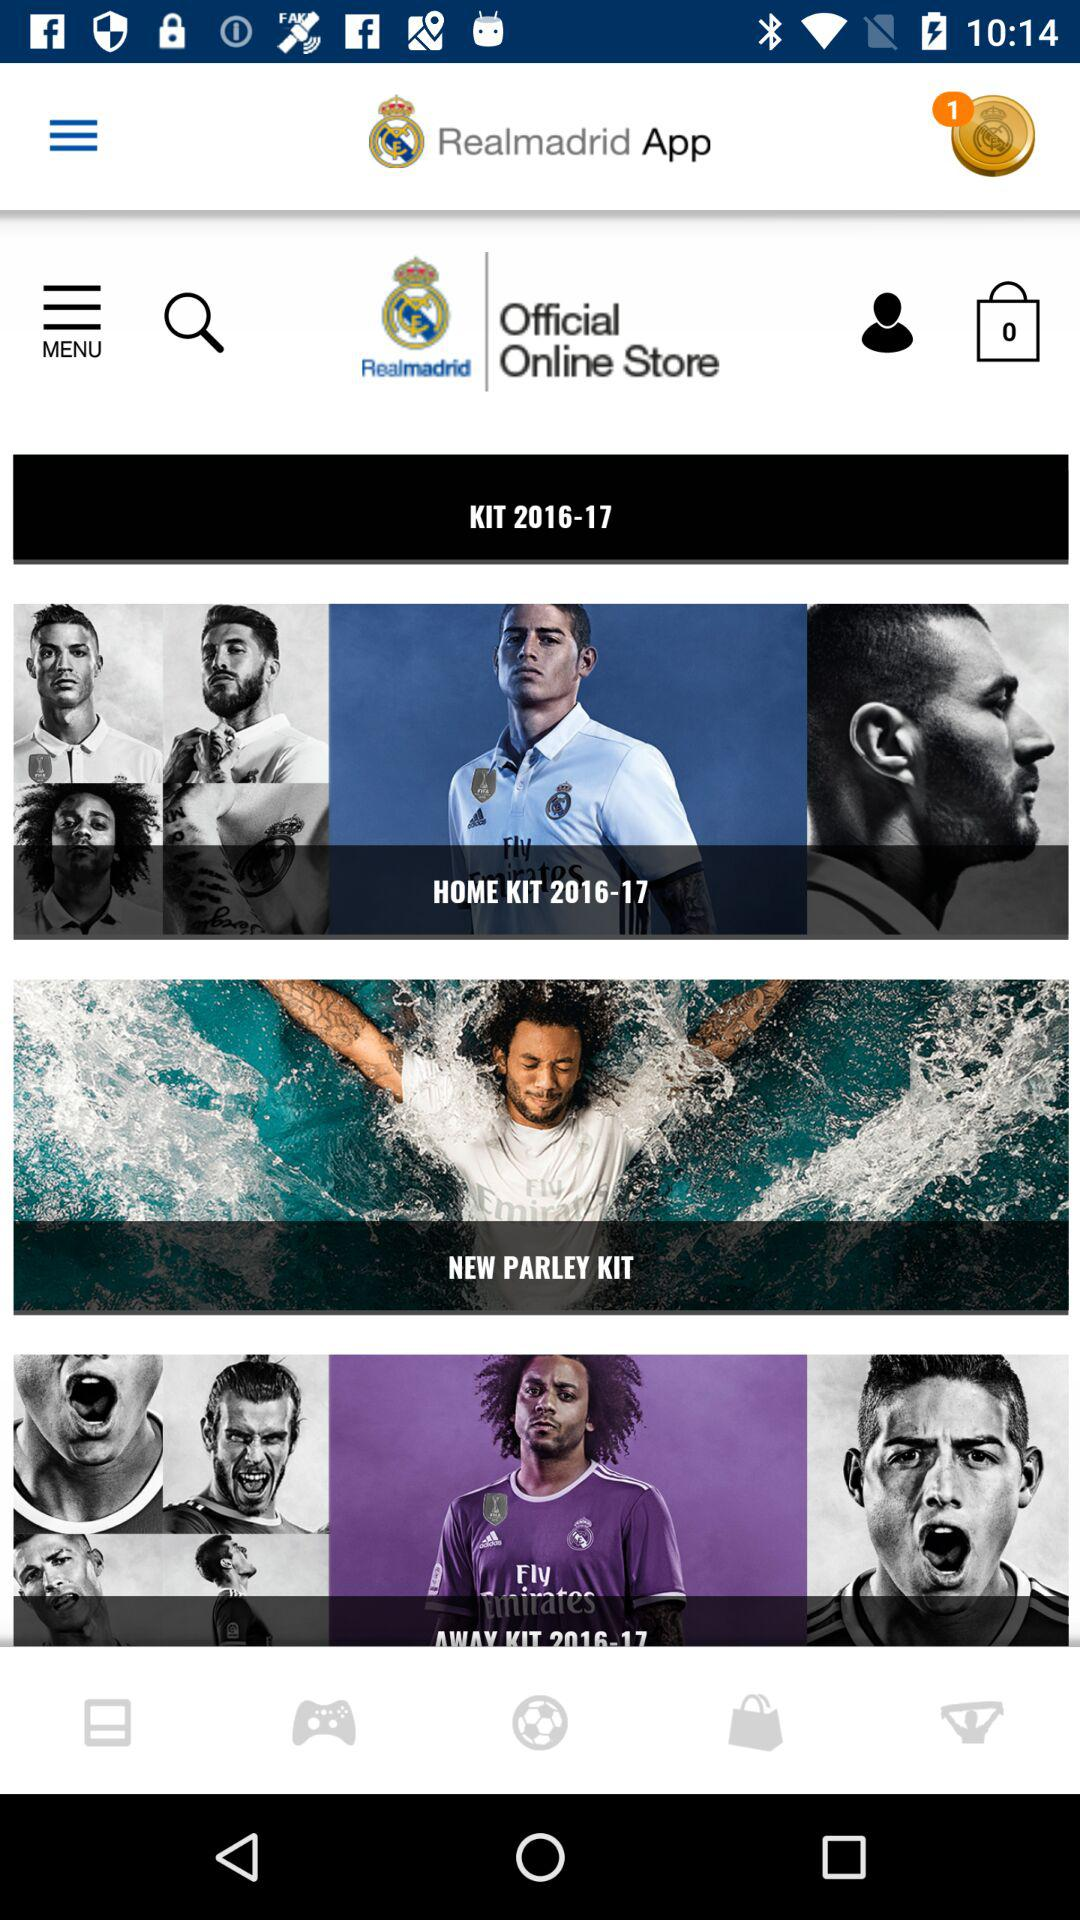How many notifications are pending? There is one notification pending. 